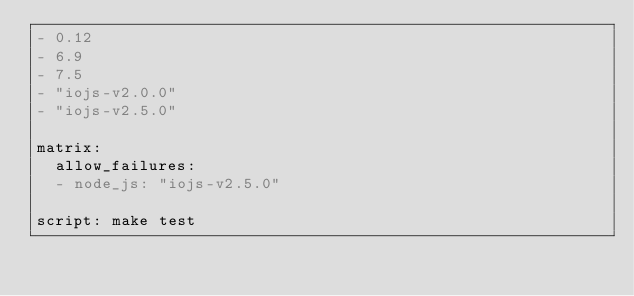Convert code to text. <code><loc_0><loc_0><loc_500><loc_500><_YAML_>- 0.12
- 6.9
- 7.5
- "iojs-v2.0.0"
- "iojs-v2.5.0"

matrix:
  allow_failures:
  - node_js: "iojs-v2.5.0"

script: make test
</code> 